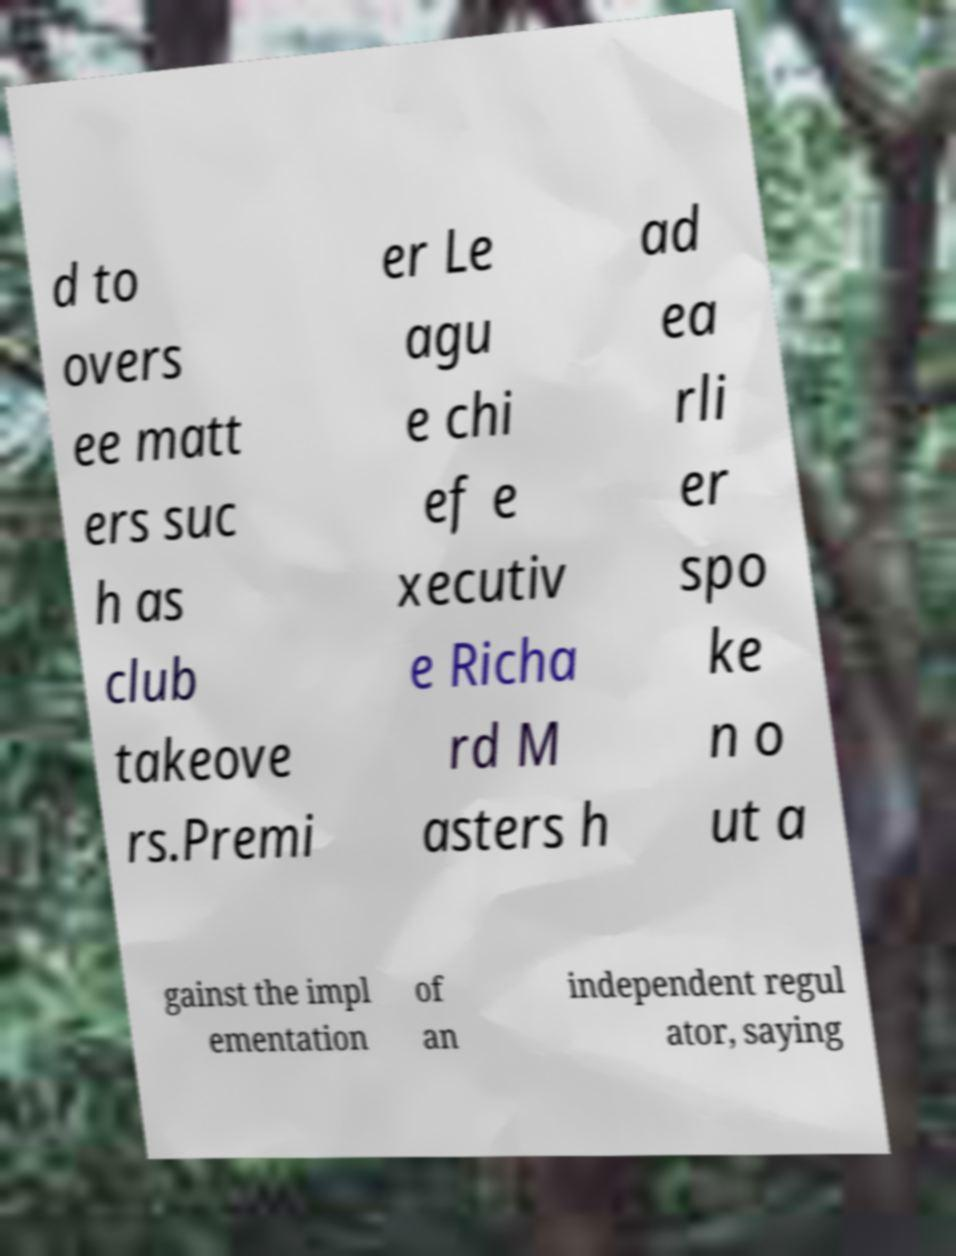Please read and relay the text visible in this image. What does it say? d to overs ee matt ers suc h as club takeove rs.Premi er Le agu e chi ef e xecutiv e Richa rd M asters h ad ea rli er spo ke n o ut a gainst the impl ementation of an independent regul ator, saying 